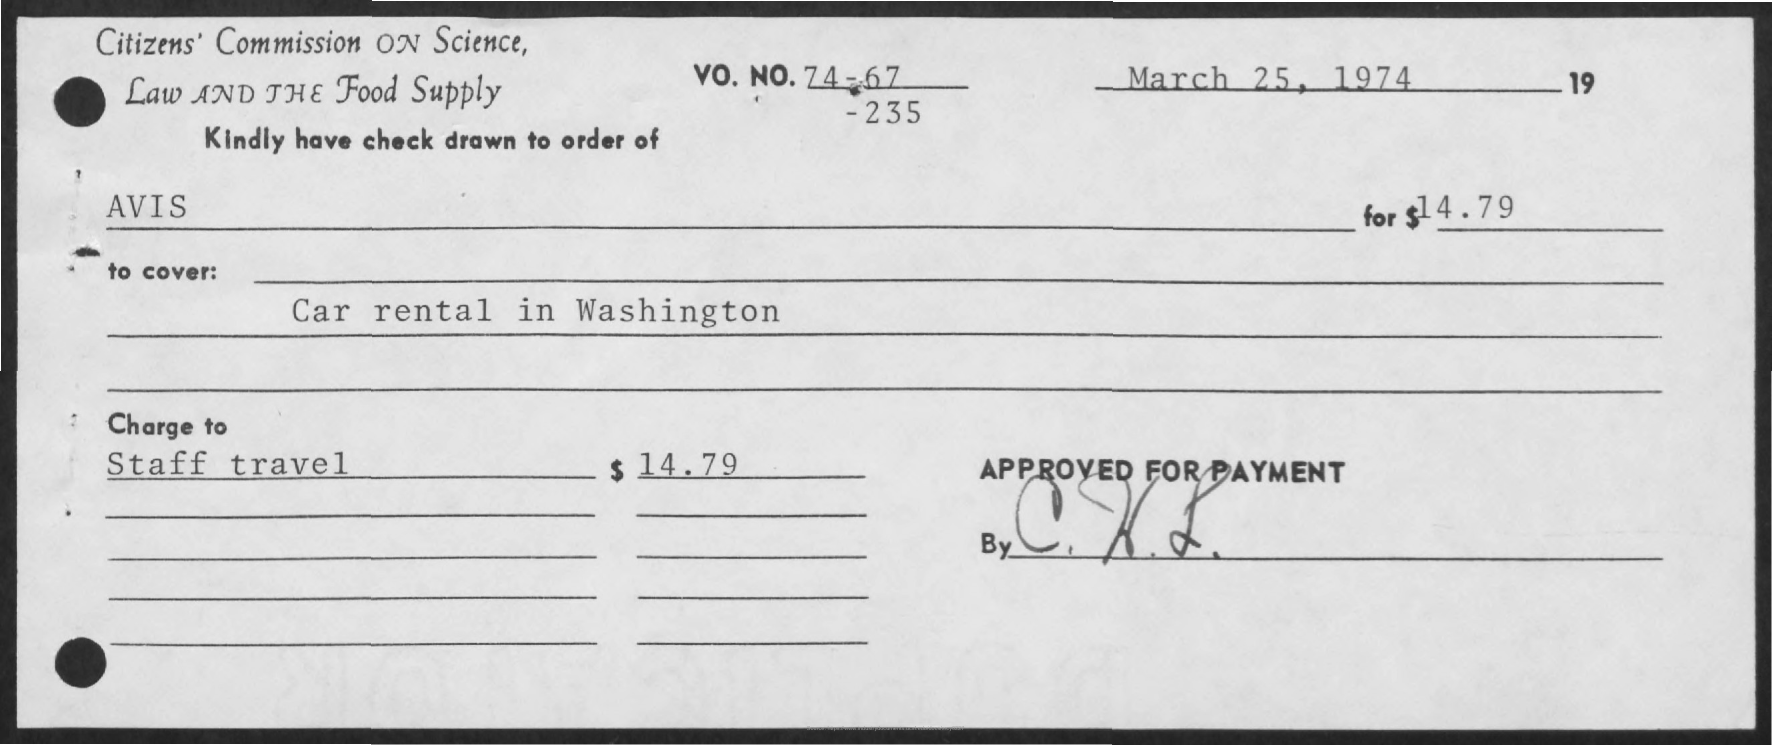What is the date on the document?
Provide a short and direct response. March 25, 1974. The check is drawn to the order of whom?
Offer a terse response. AVIS. What is the Amount?
Offer a terse response. $14.79. What is the "Charge to" for Staff Travel?
Give a very brief answer. $14.79. 